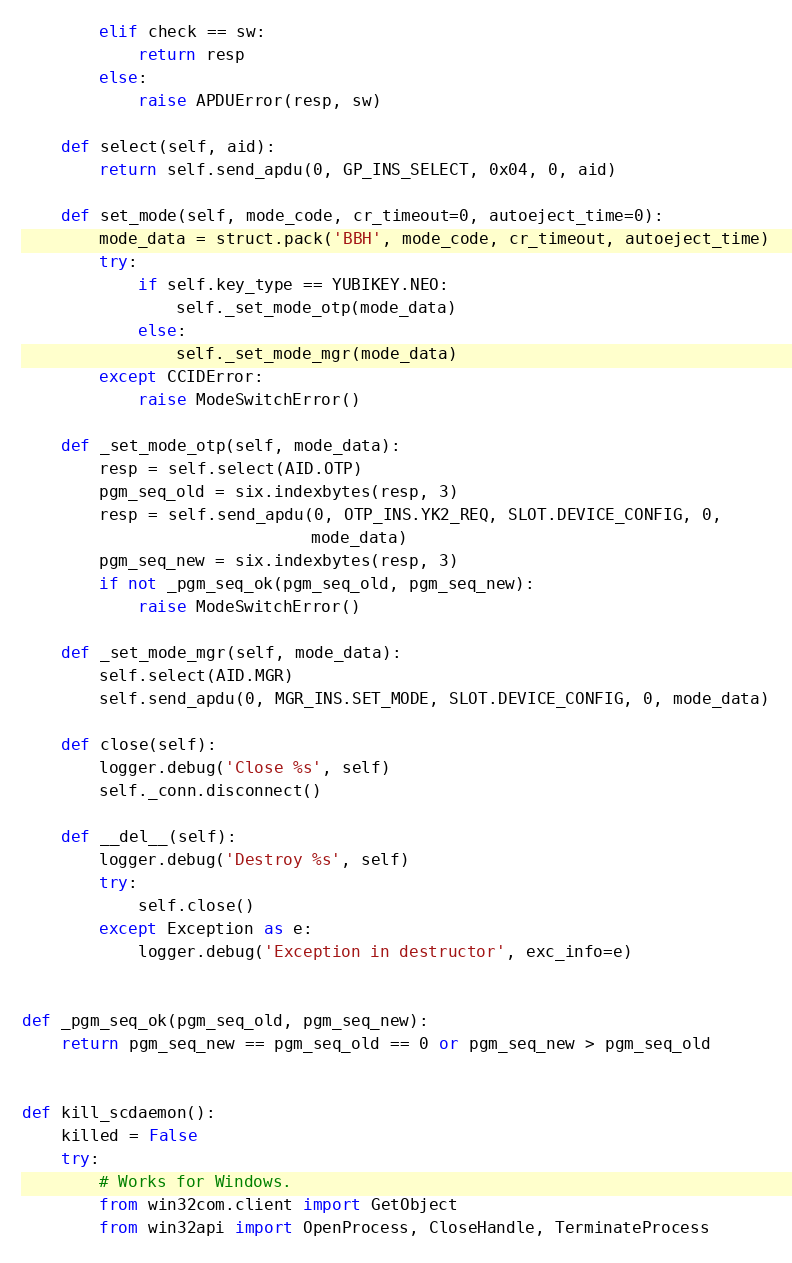<code> <loc_0><loc_0><loc_500><loc_500><_Python_>        elif check == sw:
            return resp
        else:
            raise APDUError(resp, sw)

    def select(self, aid):
        return self.send_apdu(0, GP_INS_SELECT, 0x04, 0, aid)

    def set_mode(self, mode_code, cr_timeout=0, autoeject_time=0):
        mode_data = struct.pack('BBH', mode_code, cr_timeout, autoeject_time)
        try:
            if self.key_type == YUBIKEY.NEO:
                self._set_mode_otp(mode_data)
            else:
                self._set_mode_mgr(mode_data)
        except CCIDError:
            raise ModeSwitchError()

    def _set_mode_otp(self, mode_data):
        resp = self.select(AID.OTP)
        pgm_seq_old = six.indexbytes(resp, 3)
        resp = self.send_apdu(0, OTP_INS.YK2_REQ, SLOT.DEVICE_CONFIG, 0,
                              mode_data)
        pgm_seq_new = six.indexbytes(resp, 3)
        if not _pgm_seq_ok(pgm_seq_old, pgm_seq_new):
            raise ModeSwitchError()

    def _set_mode_mgr(self, mode_data):
        self.select(AID.MGR)
        self.send_apdu(0, MGR_INS.SET_MODE, SLOT.DEVICE_CONFIG, 0, mode_data)

    def close(self):
        logger.debug('Close %s', self)
        self._conn.disconnect()

    def __del__(self):
        logger.debug('Destroy %s', self)
        try:
            self.close()
        except Exception as e:
            logger.debug('Exception in destructor', exc_info=e)


def _pgm_seq_ok(pgm_seq_old, pgm_seq_new):
    return pgm_seq_new == pgm_seq_old == 0 or pgm_seq_new > pgm_seq_old


def kill_scdaemon():
    killed = False
    try:
        # Works for Windows.
        from win32com.client import GetObject
        from win32api import OpenProcess, CloseHandle, TerminateProcess</code> 